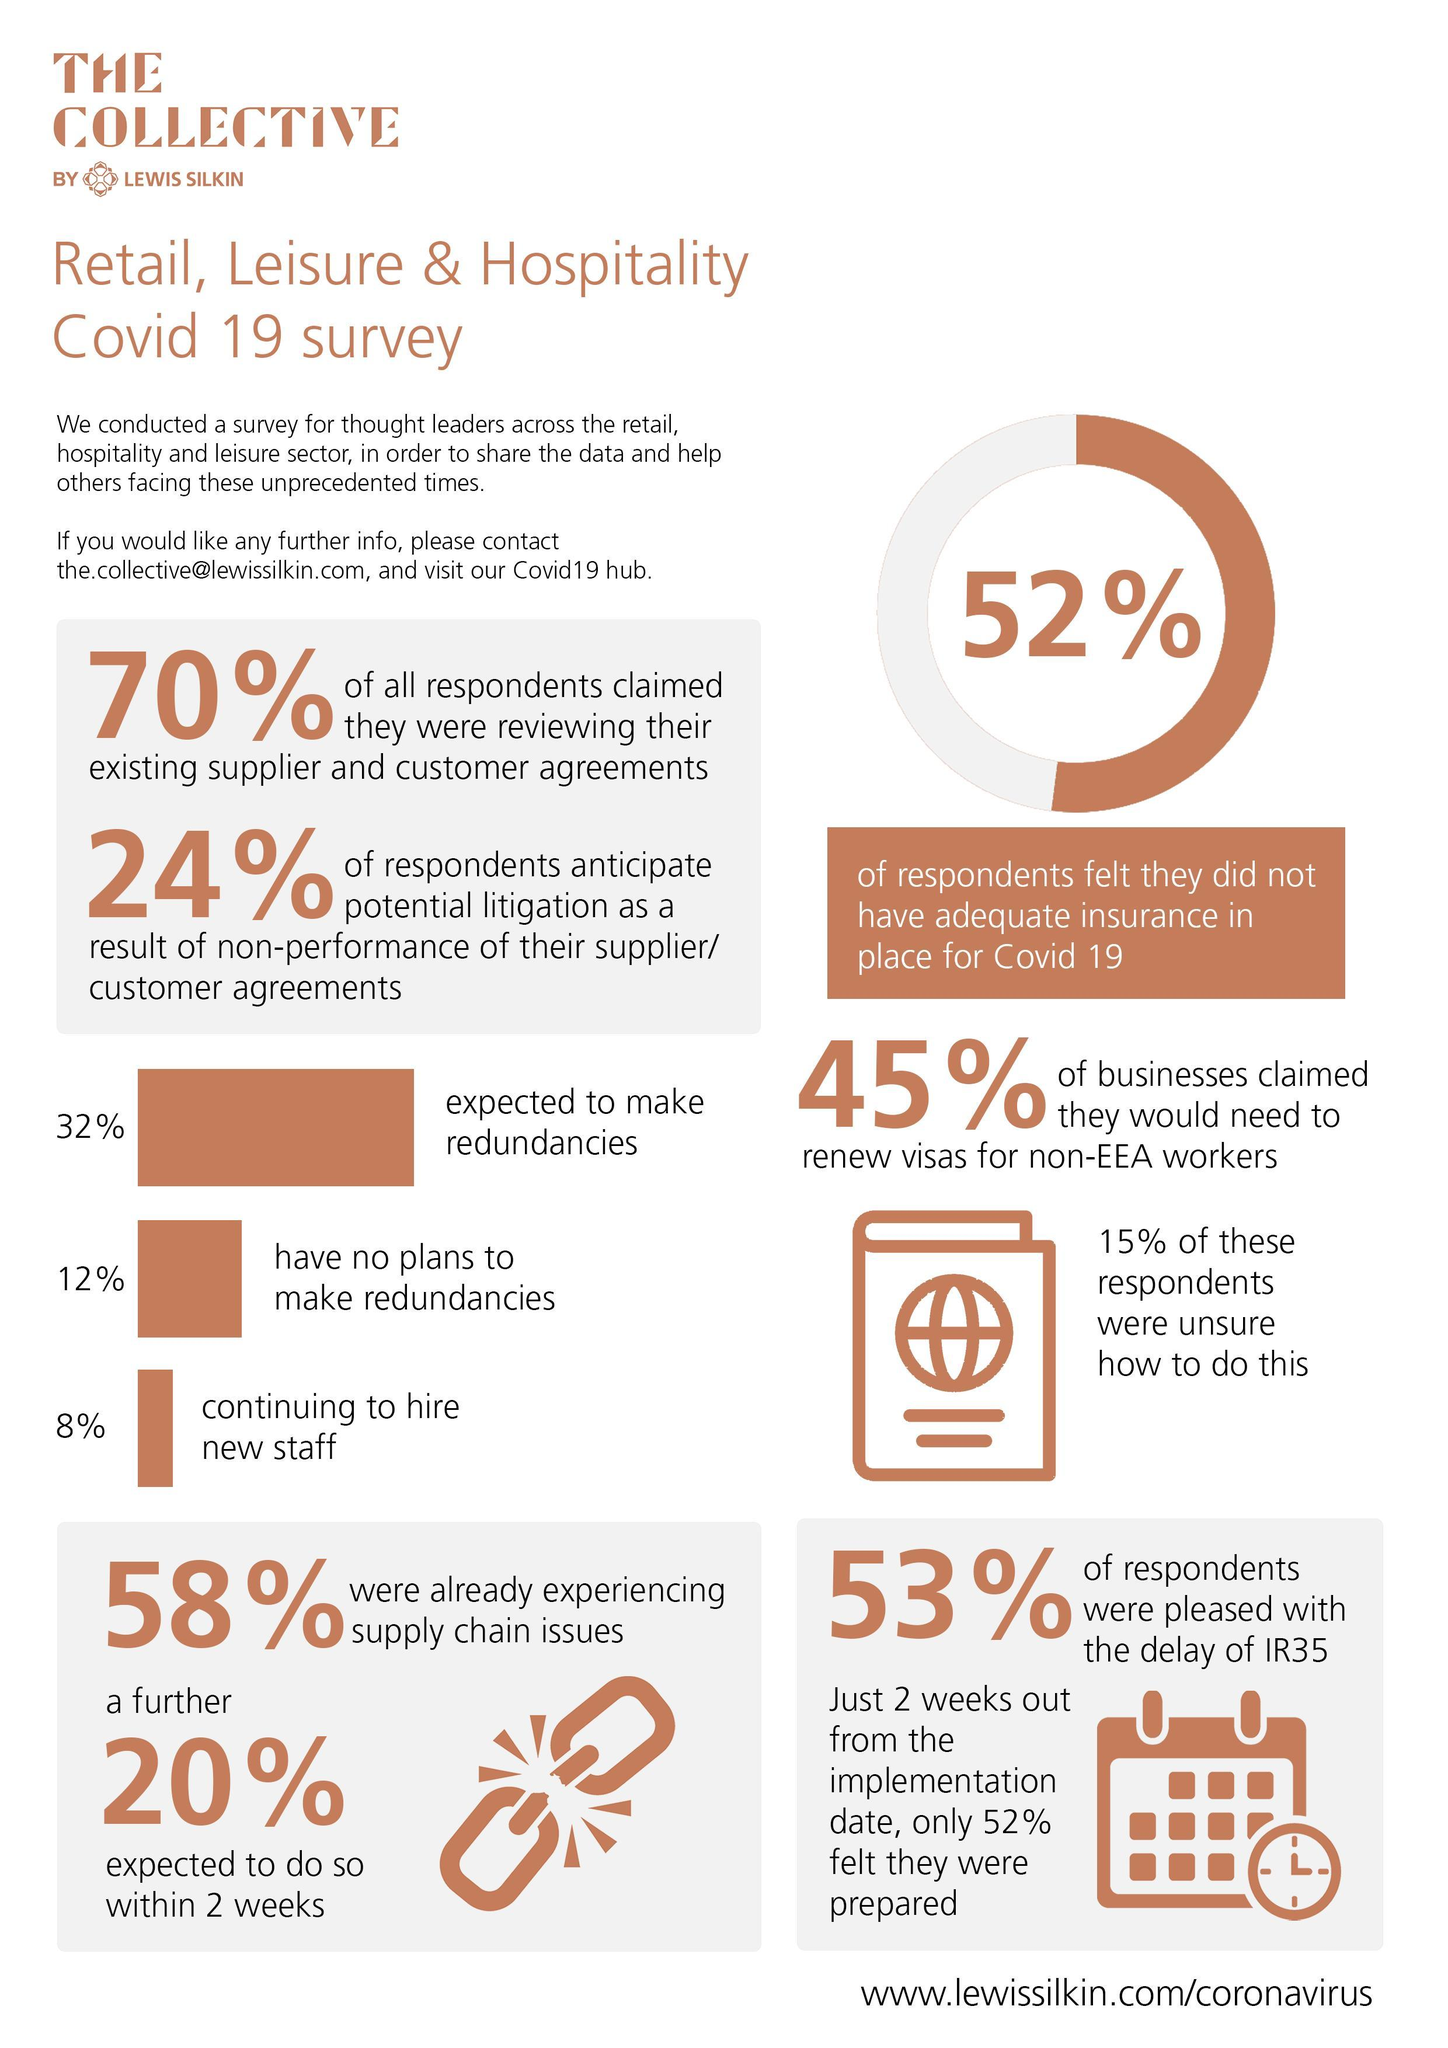What percentage of respondents stopped hiring new staff?
Answer the question with a short phrase. 92% 